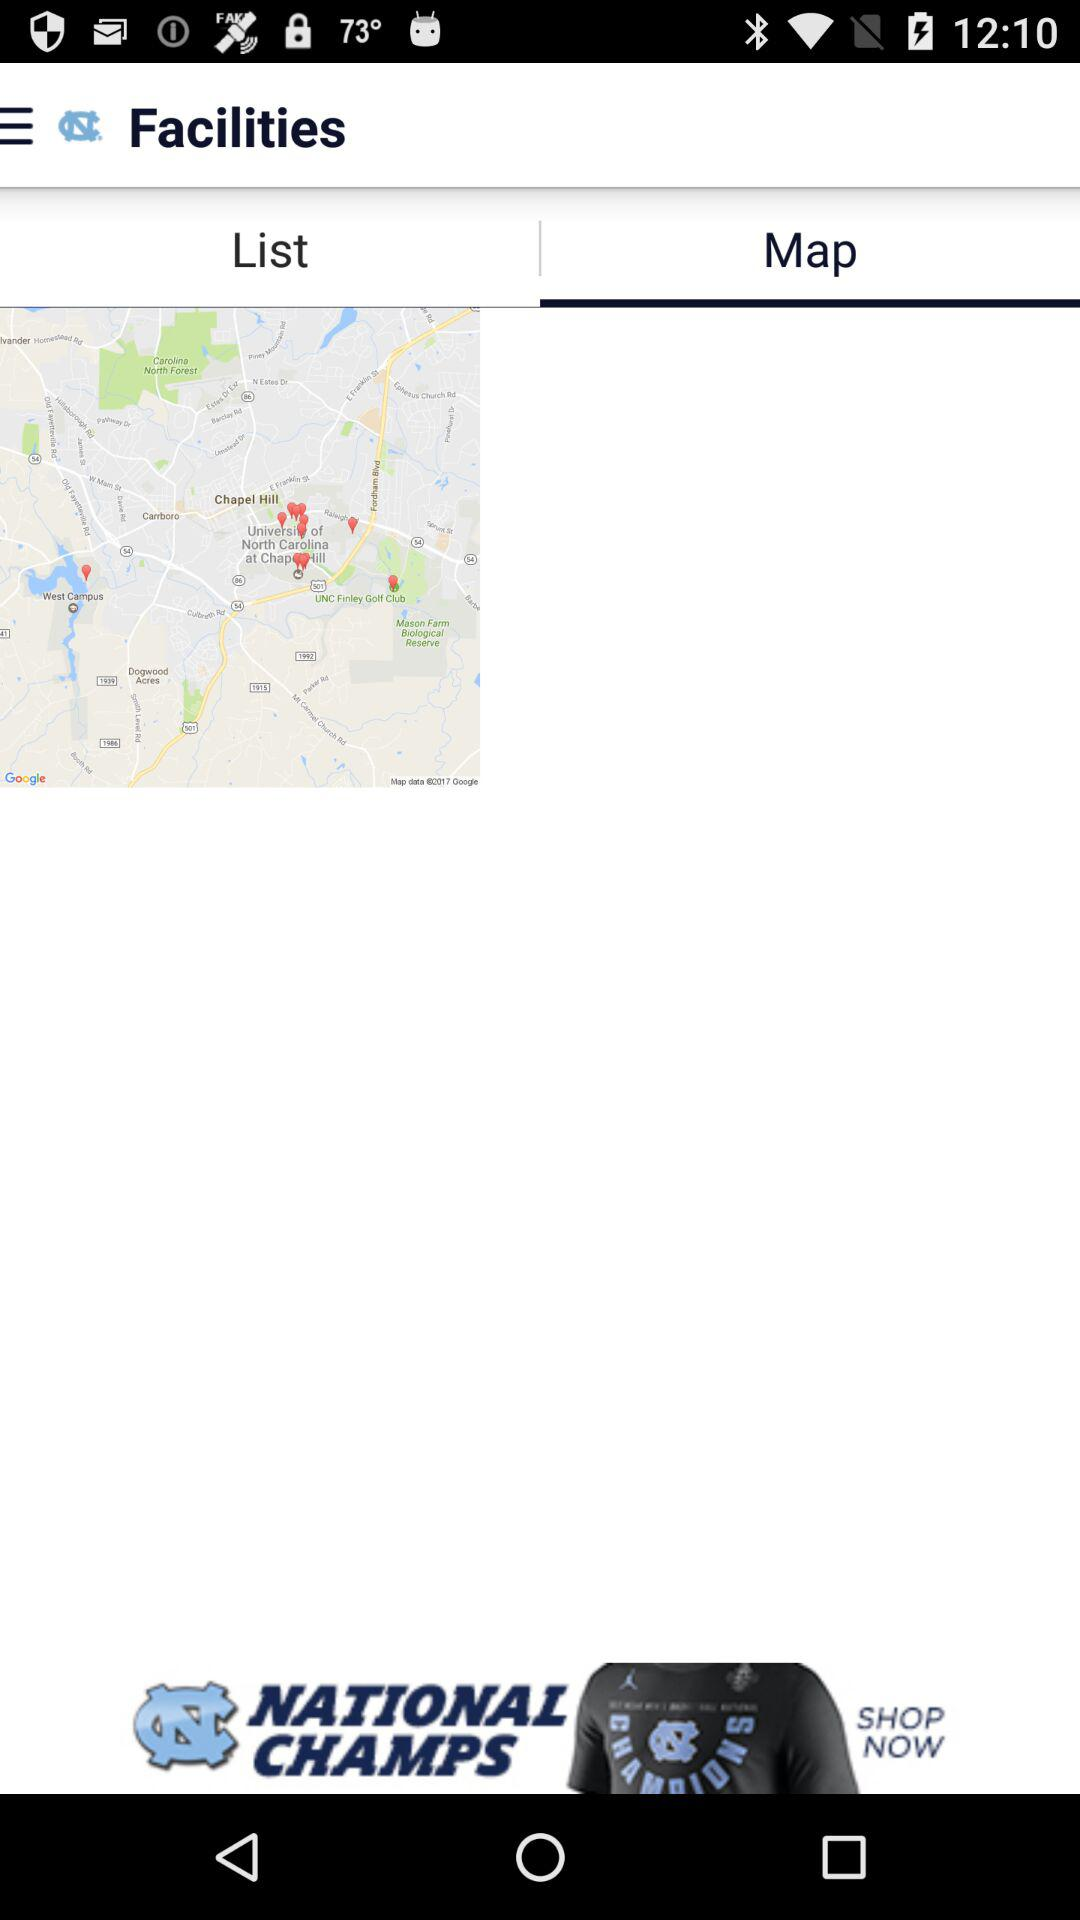Which tab is selected? The selected tab is "Map". 